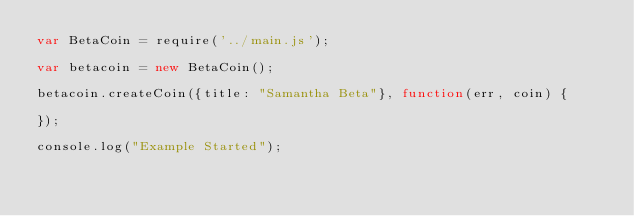Convert code to text. <code><loc_0><loc_0><loc_500><loc_500><_JavaScript_>var BetaCoin = require('../main.js');

var betacoin = new BetaCoin();

betacoin.createCoin({title: "Samantha Beta"}, function(err, coin) {

});

console.log("Example Started");</code> 